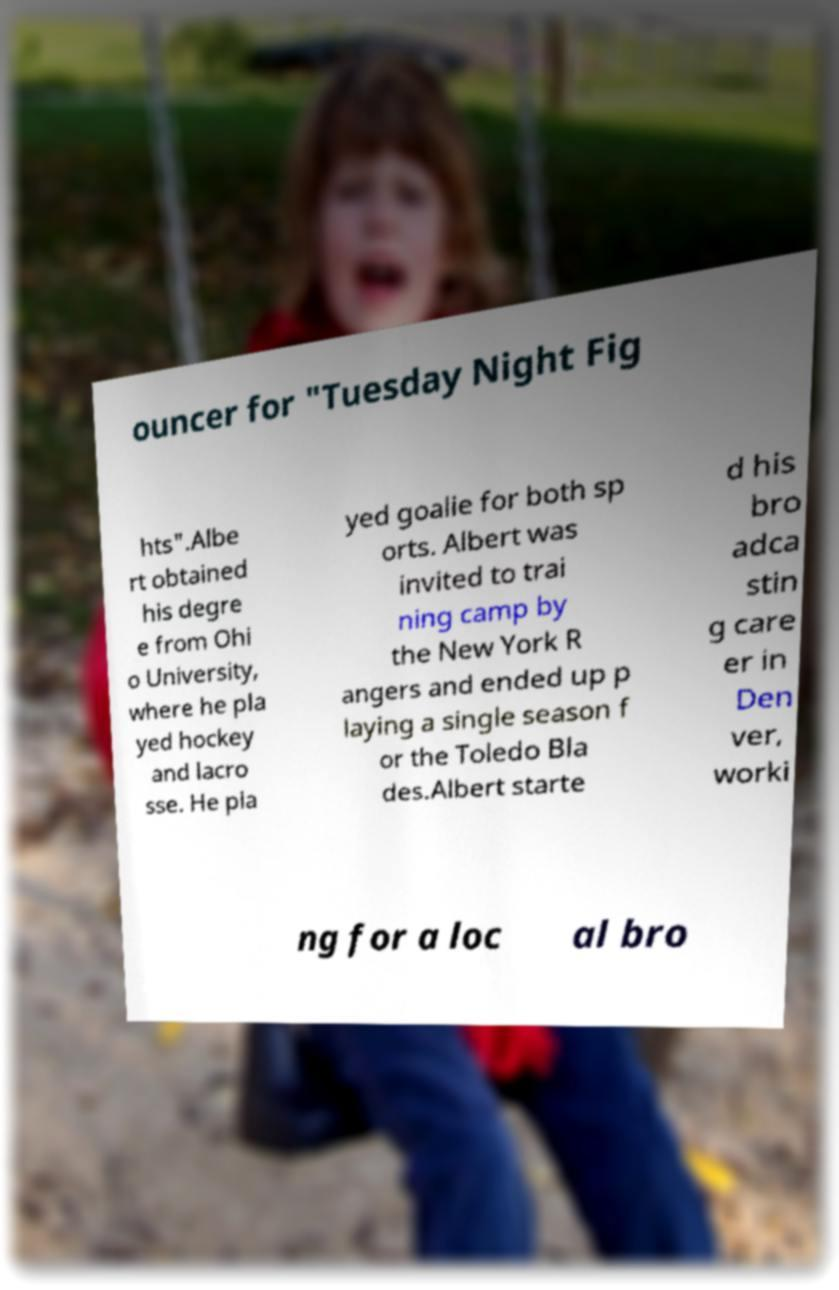For documentation purposes, I need the text within this image transcribed. Could you provide that? ouncer for "Tuesday Night Fig hts".Albe rt obtained his degre e from Ohi o University, where he pla yed hockey and lacro sse. He pla yed goalie for both sp orts. Albert was invited to trai ning camp by the New York R angers and ended up p laying a single season f or the Toledo Bla des.Albert starte d his bro adca stin g care er in Den ver, worki ng for a loc al bro 